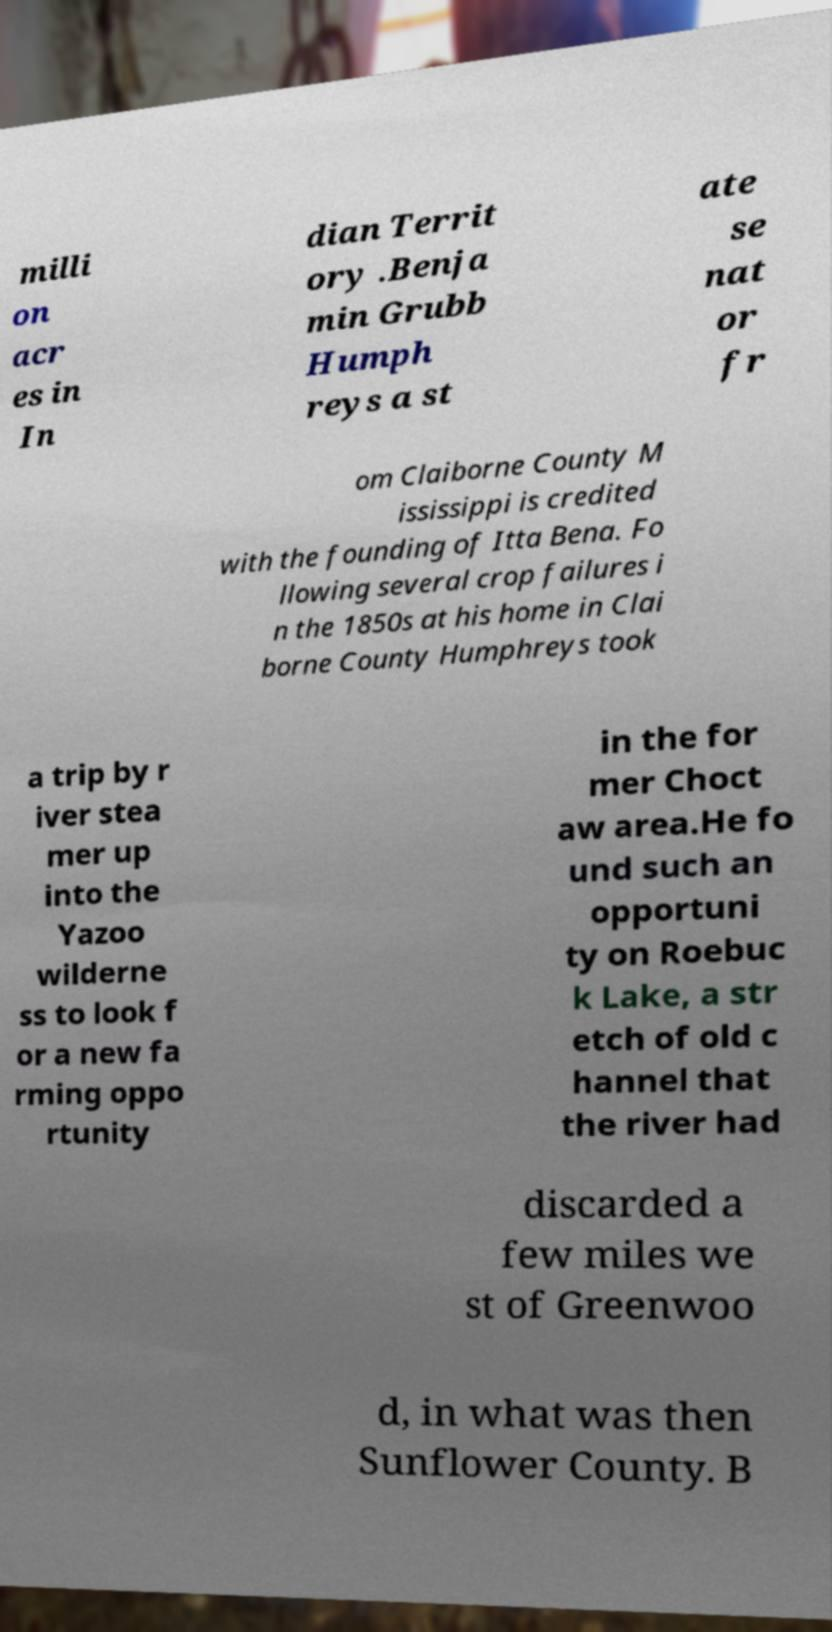Please read and relay the text visible in this image. What does it say? milli on acr es in In dian Territ ory .Benja min Grubb Humph reys a st ate se nat or fr om Claiborne County M ississippi is credited with the founding of Itta Bena. Fo llowing several crop failures i n the 1850s at his home in Clai borne County Humphreys took a trip by r iver stea mer up into the Yazoo wilderne ss to look f or a new fa rming oppo rtunity in the for mer Choct aw area.He fo und such an opportuni ty on Roebuc k Lake, a str etch of old c hannel that the river had discarded a few miles we st of Greenwoo d, in what was then Sunflower County. B 